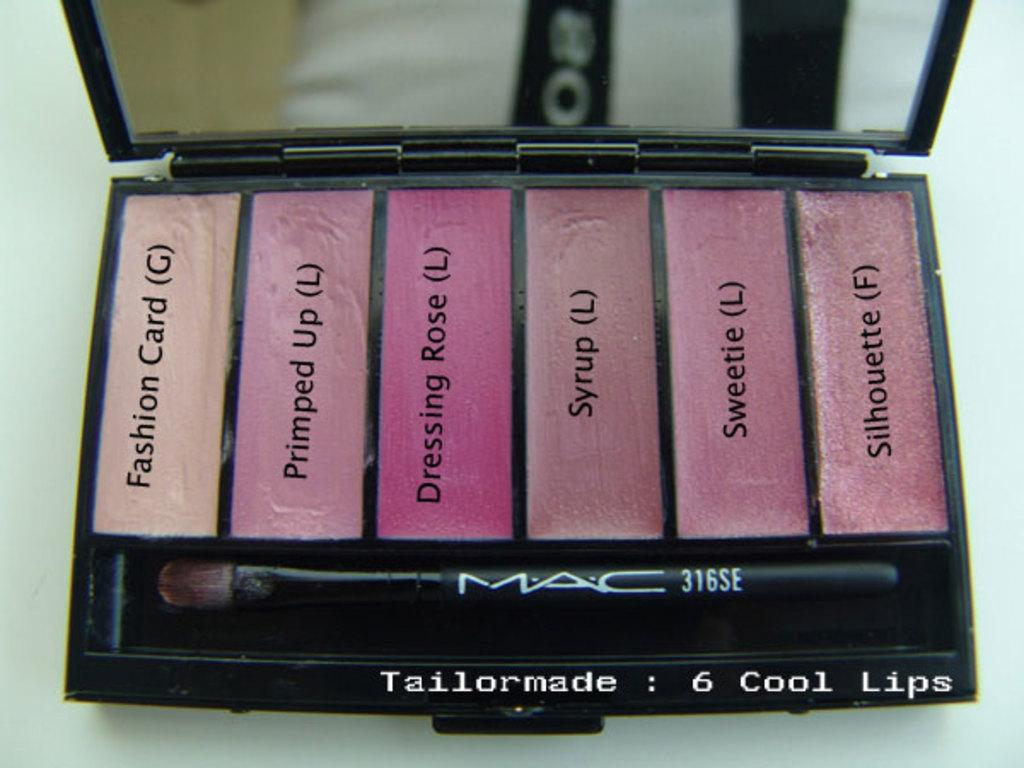<image>
Give a short and clear explanation of the subsequent image. A MAC brand cosmetics case has six shades of lipstick. 